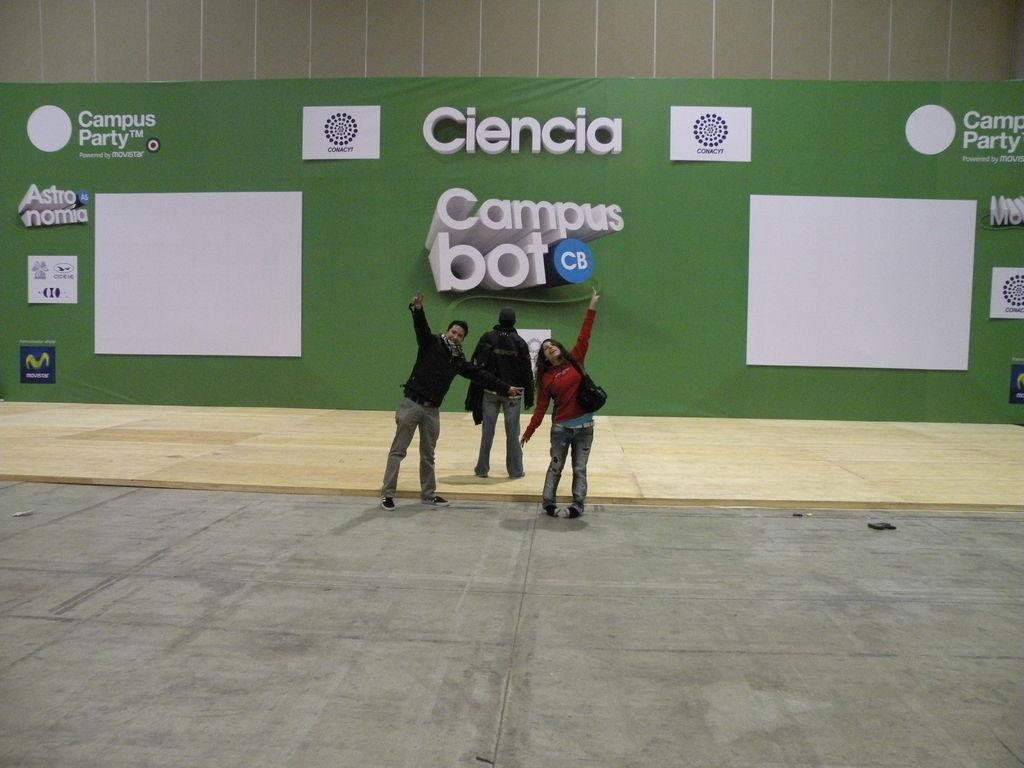In one or two sentences, can you explain what this image depicts? In the image in the center, we can see three persons are standing and holding some objects. In the background there is a wall and banners. 